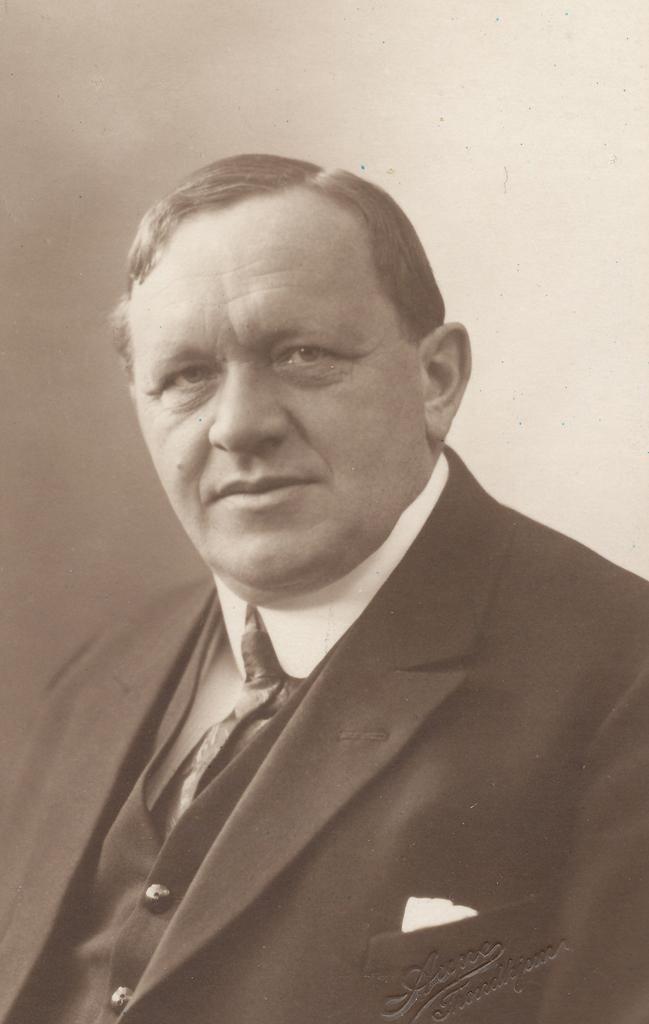What is the color scheme of the image? The image is black and white. Who is in the image? There is a man in the image. What is the man wearing? The man is wearing a suit. What is the man doing in the image? The man is posing for the picture. What color is the background of the image? The background of the image is white. What type of note is the man holding in the image? There is: There is no note present in the image. What is the man eating for lunch in the image? There is no lunch or any food visible in the image. 